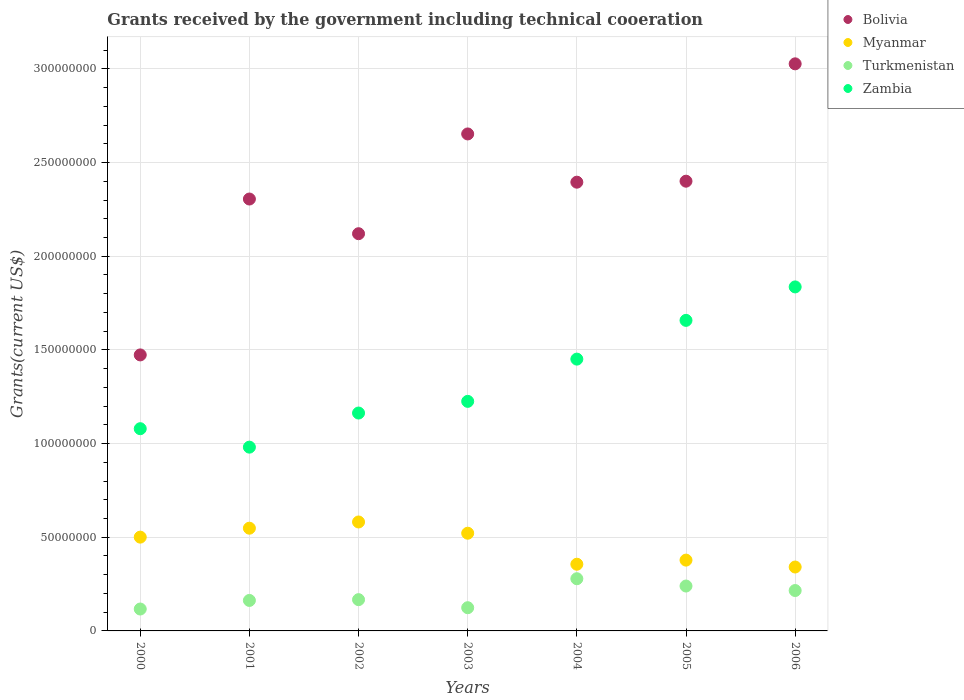How many different coloured dotlines are there?
Offer a very short reply. 4. What is the total grants received by the government in Myanmar in 2006?
Your answer should be very brief. 3.41e+07. Across all years, what is the maximum total grants received by the government in Bolivia?
Your answer should be compact. 3.03e+08. Across all years, what is the minimum total grants received by the government in Myanmar?
Keep it short and to the point. 3.41e+07. In which year was the total grants received by the government in Turkmenistan minimum?
Your answer should be very brief. 2000. What is the total total grants received by the government in Zambia in the graph?
Give a very brief answer. 9.39e+08. What is the difference between the total grants received by the government in Myanmar in 2001 and that in 2005?
Provide a succinct answer. 1.70e+07. What is the difference between the total grants received by the government in Zambia in 2004 and the total grants received by the government in Bolivia in 2002?
Your response must be concise. -6.69e+07. What is the average total grants received by the government in Myanmar per year?
Provide a succinct answer. 4.61e+07. In the year 2000, what is the difference between the total grants received by the government in Zambia and total grants received by the government in Myanmar?
Keep it short and to the point. 5.79e+07. What is the ratio of the total grants received by the government in Myanmar in 2001 to that in 2006?
Offer a very short reply. 1.61. Is the total grants received by the government in Bolivia in 2003 less than that in 2004?
Give a very brief answer. No. What is the difference between the highest and the second highest total grants received by the government in Zambia?
Offer a terse response. 1.79e+07. What is the difference between the highest and the lowest total grants received by the government in Bolivia?
Offer a very short reply. 1.55e+08. Is it the case that in every year, the sum of the total grants received by the government in Turkmenistan and total grants received by the government in Bolivia  is greater than the total grants received by the government in Zambia?
Keep it short and to the point. Yes. Does the total grants received by the government in Myanmar monotonically increase over the years?
Keep it short and to the point. No. Is the total grants received by the government in Zambia strictly greater than the total grants received by the government in Bolivia over the years?
Make the answer very short. No. Is the total grants received by the government in Zambia strictly less than the total grants received by the government in Bolivia over the years?
Your answer should be very brief. Yes. Are the values on the major ticks of Y-axis written in scientific E-notation?
Offer a terse response. No. Does the graph contain any zero values?
Provide a succinct answer. No. Where does the legend appear in the graph?
Make the answer very short. Top right. How many legend labels are there?
Give a very brief answer. 4. What is the title of the graph?
Provide a short and direct response. Grants received by the government including technical cooeration. Does "St. Martin (French part)" appear as one of the legend labels in the graph?
Ensure brevity in your answer.  No. What is the label or title of the Y-axis?
Give a very brief answer. Grants(current US$). What is the Grants(current US$) of Bolivia in 2000?
Your answer should be compact. 1.47e+08. What is the Grants(current US$) of Myanmar in 2000?
Provide a short and direct response. 5.01e+07. What is the Grants(current US$) in Turkmenistan in 2000?
Offer a very short reply. 1.17e+07. What is the Grants(current US$) in Zambia in 2000?
Your response must be concise. 1.08e+08. What is the Grants(current US$) in Bolivia in 2001?
Keep it short and to the point. 2.31e+08. What is the Grants(current US$) of Myanmar in 2001?
Offer a very short reply. 5.48e+07. What is the Grants(current US$) of Turkmenistan in 2001?
Your answer should be very brief. 1.63e+07. What is the Grants(current US$) of Zambia in 2001?
Your response must be concise. 9.81e+07. What is the Grants(current US$) of Bolivia in 2002?
Your response must be concise. 2.12e+08. What is the Grants(current US$) in Myanmar in 2002?
Your answer should be very brief. 5.82e+07. What is the Grants(current US$) of Turkmenistan in 2002?
Provide a succinct answer. 1.67e+07. What is the Grants(current US$) of Zambia in 2002?
Give a very brief answer. 1.16e+08. What is the Grants(current US$) of Bolivia in 2003?
Provide a short and direct response. 2.65e+08. What is the Grants(current US$) of Myanmar in 2003?
Give a very brief answer. 5.22e+07. What is the Grants(current US$) of Turkmenistan in 2003?
Your answer should be compact. 1.24e+07. What is the Grants(current US$) in Zambia in 2003?
Make the answer very short. 1.23e+08. What is the Grants(current US$) in Bolivia in 2004?
Give a very brief answer. 2.40e+08. What is the Grants(current US$) in Myanmar in 2004?
Your answer should be compact. 3.56e+07. What is the Grants(current US$) of Turkmenistan in 2004?
Make the answer very short. 2.79e+07. What is the Grants(current US$) of Zambia in 2004?
Keep it short and to the point. 1.45e+08. What is the Grants(current US$) in Bolivia in 2005?
Your answer should be very brief. 2.40e+08. What is the Grants(current US$) in Myanmar in 2005?
Offer a terse response. 3.78e+07. What is the Grants(current US$) of Turkmenistan in 2005?
Your answer should be compact. 2.40e+07. What is the Grants(current US$) of Zambia in 2005?
Offer a very short reply. 1.66e+08. What is the Grants(current US$) of Bolivia in 2006?
Ensure brevity in your answer.  3.03e+08. What is the Grants(current US$) of Myanmar in 2006?
Offer a terse response. 3.41e+07. What is the Grants(current US$) of Turkmenistan in 2006?
Provide a succinct answer. 2.16e+07. What is the Grants(current US$) of Zambia in 2006?
Make the answer very short. 1.84e+08. Across all years, what is the maximum Grants(current US$) in Bolivia?
Offer a very short reply. 3.03e+08. Across all years, what is the maximum Grants(current US$) in Myanmar?
Your response must be concise. 5.82e+07. Across all years, what is the maximum Grants(current US$) in Turkmenistan?
Your answer should be compact. 2.79e+07. Across all years, what is the maximum Grants(current US$) in Zambia?
Make the answer very short. 1.84e+08. Across all years, what is the minimum Grants(current US$) of Bolivia?
Your response must be concise. 1.47e+08. Across all years, what is the minimum Grants(current US$) in Myanmar?
Your response must be concise. 3.41e+07. Across all years, what is the minimum Grants(current US$) in Turkmenistan?
Keep it short and to the point. 1.17e+07. Across all years, what is the minimum Grants(current US$) of Zambia?
Offer a very short reply. 9.81e+07. What is the total Grants(current US$) in Bolivia in the graph?
Give a very brief answer. 1.64e+09. What is the total Grants(current US$) in Myanmar in the graph?
Make the answer very short. 3.23e+08. What is the total Grants(current US$) of Turkmenistan in the graph?
Provide a short and direct response. 1.30e+08. What is the total Grants(current US$) of Zambia in the graph?
Offer a very short reply. 9.39e+08. What is the difference between the Grants(current US$) in Bolivia in 2000 and that in 2001?
Offer a terse response. -8.32e+07. What is the difference between the Grants(current US$) of Myanmar in 2000 and that in 2001?
Provide a succinct answer. -4.77e+06. What is the difference between the Grants(current US$) in Turkmenistan in 2000 and that in 2001?
Keep it short and to the point. -4.58e+06. What is the difference between the Grants(current US$) of Zambia in 2000 and that in 2001?
Offer a very short reply. 9.85e+06. What is the difference between the Grants(current US$) of Bolivia in 2000 and that in 2002?
Make the answer very short. -6.47e+07. What is the difference between the Grants(current US$) of Myanmar in 2000 and that in 2002?
Your response must be concise. -8.09e+06. What is the difference between the Grants(current US$) of Turkmenistan in 2000 and that in 2002?
Your answer should be compact. -5.00e+06. What is the difference between the Grants(current US$) in Zambia in 2000 and that in 2002?
Your answer should be very brief. -8.36e+06. What is the difference between the Grants(current US$) of Bolivia in 2000 and that in 2003?
Provide a succinct answer. -1.18e+08. What is the difference between the Grants(current US$) of Myanmar in 2000 and that in 2003?
Make the answer very short. -2.09e+06. What is the difference between the Grants(current US$) in Turkmenistan in 2000 and that in 2003?
Keep it short and to the point. -7.00e+05. What is the difference between the Grants(current US$) of Zambia in 2000 and that in 2003?
Give a very brief answer. -1.46e+07. What is the difference between the Grants(current US$) in Bolivia in 2000 and that in 2004?
Give a very brief answer. -9.22e+07. What is the difference between the Grants(current US$) of Myanmar in 2000 and that in 2004?
Your answer should be very brief. 1.45e+07. What is the difference between the Grants(current US$) of Turkmenistan in 2000 and that in 2004?
Keep it short and to the point. -1.62e+07. What is the difference between the Grants(current US$) of Zambia in 2000 and that in 2004?
Your response must be concise. -3.71e+07. What is the difference between the Grants(current US$) in Bolivia in 2000 and that in 2005?
Your response must be concise. -9.27e+07. What is the difference between the Grants(current US$) in Myanmar in 2000 and that in 2005?
Ensure brevity in your answer.  1.23e+07. What is the difference between the Grants(current US$) in Turkmenistan in 2000 and that in 2005?
Offer a very short reply. -1.23e+07. What is the difference between the Grants(current US$) of Zambia in 2000 and that in 2005?
Offer a terse response. -5.78e+07. What is the difference between the Grants(current US$) in Bolivia in 2000 and that in 2006?
Keep it short and to the point. -1.55e+08. What is the difference between the Grants(current US$) in Myanmar in 2000 and that in 2006?
Keep it short and to the point. 1.60e+07. What is the difference between the Grants(current US$) of Turkmenistan in 2000 and that in 2006?
Ensure brevity in your answer.  -9.87e+06. What is the difference between the Grants(current US$) in Zambia in 2000 and that in 2006?
Provide a short and direct response. -7.57e+07. What is the difference between the Grants(current US$) in Bolivia in 2001 and that in 2002?
Ensure brevity in your answer.  1.85e+07. What is the difference between the Grants(current US$) in Myanmar in 2001 and that in 2002?
Offer a very short reply. -3.32e+06. What is the difference between the Grants(current US$) of Turkmenistan in 2001 and that in 2002?
Make the answer very short. -4.20e+05. What is the difference between the Grants(current US$) of Zambia in 2001 and that in 2002?
Provide a short and direct response. -1.82e+07. What is the difference between the Grants(current US$) in Bolivia in 2001 and that in 2003?
Give a very brief answer. -3.47e+07. What is the difference between the Grants(current US$) of Myanmar in 2001 and that in 2003?
Ensure brevity in your answer.  2.68e+06. What is the difference between the Grants(current US$) of Turkmenistan in 2001 and that in 2003?
Your answer should be very brief. 3.88e+06. What is the difference between the Grants(current US$) of Zambia in 2001 and that in 2003?
Give a very brief answer. -2.44e+07. What is the difference between the Grants(current US$) of Bolivia in 2001 and that in 2004?
Your answer should be very brief. -8.99e+06. What is the difference between the Grants(current US$) in Myanmar in 2001 and that in 2004?
Offer a terse response. 1.92e+07. What is the difference between the Grants(current US$) of Turkmenistan in 2001 and that in 2004?
Keep it short and to the point. -1.16e+07. What is the difference between the Grants(current US$) in Zambia in 2001 and that in 2004?
Give a very brief answer. -4.70e+07. What is the difference between the Grants(current US$) of Bolivia in 2001 and that in 2005?
Keep it short and to the point. -9.52e+06. What is the difference between the Grants(current US$) of Myanmar in 2001 and that in 2005?
Provide a short and direct response. 1.70e+07. What is the difference between the Grants(current US$) in Turkmenistan in 2001 and that in 2005?
Offer a very short reply. -7.69e+06. What is the difference between the Grants(current US$) in Zambia in 2001 and that in 2005?
Provide a short and direct response. -6.77e+07. What is the difference between the Grants(current US$) in Bolivia in 2001 and that in 2006?
Your response must be concise. -7.22e+07. What is the difference between the Grants(current US$) of Myanmar in 2001 and that in 2006?
Offer a terse response. 2.07e+07. What is the difference between the Grants(current US$) of Turkmenistan in 2001 and that in 2006?
Give a very brief answer. -5.29e+06. What is the difference between the Grants(current US$) in Zambia in 2001 and that in 2006?
Your response must be concise. -8.55e+07. What is the difference between the Grants(current US$) in Bolivia in 2002 and that in 2003?
Offer a very short reply. -5.32e+07. What is the difference between the Grants(current US$) in Turkmenistan in 2002 and that in 2003?
Offer a terse response. 4.30e+06. What is the difference between the Grants(current US$) of Zambia in 2002 and that in 2003?
Your response must be concise. -6.23e+06. What is the difference between the Grants(current US$) of Bolivia in 2002 and that in 2004?
Give a very brief answer. -2.75e+07. What is the difference between the Grants(current US$) of Myanmar in 2002 and that in 2004?
Provide a short and direct response. 2.26e+07. What is the difference between the Grants(current US$) of Turkmenistan in 2002 and that in 2004?
Provide a short and direct response. -1.12e+07. What is the difference between the Grants(current US$) in Zambia in 2002 and that in 2004?
Make the answer very short. -2.88e+07. What is the difference between the Grants(current US$) in Bolivia in 2002 and that in 2005?
Make the answer very short. -2.80e+07. What is the difference between the Grants(current US$) of Myanmar in 2002 and that in 2005?
Your answer should be very brief. 2.04e+07. What is the difference between the Grants(current US$) of Turkmenistan in 2002 and that in 2005?
Keep it short and to the point. -7.27e+06. What is the difference between the Grants(current US$) in Zambia in 2002 and that in 2005?
Ensure brevity in your answer.  -4.95e+07. What is the difference between the Grants(current US$) in Bolivia in 2002 and that in 2006?
Give a very brief answer. -9.07e+07. What is the difference between the Grants(current US$) in Myanmar in 2002 and that in 2006?
Offer a very short reply. 2.40e+07. What is the difference between the Grants(current US$) of Turkmenistan in 2002 and that in 2006?
Keep it short and to the point. -4.87e+06. What is the difference between the Grants(current US$) of Zambia in 2002 and that in 2006?
Give a very brief answer. -6.73e+07. What is the difference between the Grants(current US$) in Bolivia in 2003 and that in 2004?
Your answer should be very brief. 2.58e+07. What is the difference between the Grants(current US$) of Myanmar in 2003 and that in 2004?
Provide a succinct answer. 1.66e+07. What is the difference between the Grants(current US$) of Turkmenistan in 2003 and that in 2004?
Your response must be concise. -1.55e+07. What is the difference between the Grants(current US$) in Zambia in 2003 and that in 2004?
Make the answer very short. -2.26e+07. What is the difference between the Grants(current US$) of Bolivia in 2003 and that in 2005?
Offer a very short reply. 2.52e+07. What is the difference between the Grants(current US$) of Myanmar in 2003 and that in 2005?
Give a very brief answer. 1.44e+07. What is the difference between the Grants(current US$) in Turkmenistan in 2003 and that in 2005?
Keep it short and to the point. -1.16e+07. What is the difference between the Grants(current US$) in Zambia in 2003 and that in 2005?
Make the answer very short. -4.32e+07. What is the difference between the Grants(current US$) in Bolivia in 2003 and that in 2006?
Offer a terse response. -3.74e+07. What is the difference between the Grants(current US$) of Myanmar in 2003 and that in 2006?
Your answer should be compact. 1.80e+07. What is the difference between the Grants(current US$) of Turkmenistan in 2003 and that in 2006?
Give a very brief answer. -9.17e+06. What is the difference between the Grants(current US$) of Zambia in 2003 and that in 2006?
Your response must be concise. -6.11e+07. What is the difference between the Grants(current US$) of Bolivia in 2004 and that in 2005?
Provide a succinct answer. -5.30e+05. What is the difference between the Grants(current US$) of Myanmar in 2004 and that in 2005?
Your answer should be very brief. -2.19e+06. What is the difference between the Grants(current US$) in Turkmenistan in 2004 and that in 2005?
Provide a succinct answer. 3.90e+06. What is the difference between the Grants(current US$) in Zambia in 2004 and that in 2005?
Offer a very short reply. -2.07e+07. What is the difference between the Grants(current US$) of Bolivia in 2004 and that in 2006?
Ensure brevity in your answer.  -6.32e+07. What is the difference between the Grants(current US$) of Myanmar in 2004 and that in 2006?
Keep it short and to the point. 1.49e+06. What is the difference between the Grants(current US$) in Turkmenistan in 2004 and that in 2006?
Make the answer very short. 6.30e+06. What is the difference between the Grants(current US$) in Zambia in 2004 and that in 2006?
Your answer should be compact. -3.85e+07. What is the difference between the Grants(current US$) of Bolivia in 2005 and that in 2006?
Provide a short and direct response. -6.26e+07. What is the difference between the Grants(current US$) in Myanmar in 2005 and that in 2006?
Keep it short and to the point. 3.68e+06. What is the difference between the Grants(current US$) of Turkmenistan in 2005 and that in 2006?
Offer a terse response. 2.40e+06. What is the difference between the Grants(current US$) in Zambia in 2005 and that in 2006?
Ensure brevity in your answer.  -1.79e+07. What is the difference between the Grants(current US$) of Bolivia in 2000 and the Grants(current US$) of Myanmar in 2001?
Your answer should be very brief. 9.25e+07. What is the difference between the Grants(current US$) of Bolivia in 2000 and the Grants(current US$) of Turkmenistan in 2001?
Offer a very short reply. 1.31e+08. What is the difference between the Grants(current US$) in Bolivia in 2000 and the Grants(current US$) in Zambia in 2001?
Make the answer very short. 4.92e+07. What is the difference between the Grants(current US$) in Myanmar in 2000 and the Grants(current US$) in Turkmenistan in 2001?
Provide a succinct answer. 3.38e+07. What is the difference between the Grants(current US$) of Myanmar in 2000 and the Grants(current US$) of Zambia in 2001?
Offer a very short reply. -4.80e+07. What is the difference between the Grants(current US$) of Turkmenistan in 2000 and the Grants(current US$) of Zambia in 2001?
Your answer should be compact. -8.64e+07. What is the difference between the Grants(current US$) of Bolivia in 2000 and the Grants(current US$) of Myanmar in 2002?
Make the answer very short. 8.92e+07. What is the difference between the Grants(current US$) in Bolivia in 2000 and the Grants(current US$) in Turkmenistan in 2002?
Give a very brief answer. 1.31e+08. What is the difference between the Grants(current US$) of Bolivia in 2000 and the Grants(current US$) of Zambia in 2002?
Provide a short and direct response. 3.10e+07. What is the difference between the Grants(current US$) in Myanmar in 2000 and the Grants(current US$) in Turkmenistan in 2002?
Your response must be concise. 3.34e+07. What is the difference between the Grants(current US$) in Myanmar in 2000 and the Grants(current US$) in Zambia in 2002?
Offer a terse response. -6.62e+07. What is the difference between the Grants(current US$) of Turkmenistan in 2000 and the Grants(current US$) of Zambia in 2002?
Offer a very short reply. -1.05e+08. What is the difference between the Grants(current US$) in Bolivia in 2000 and the Grants(current US$) in Myanmar in 2003?
Provide a succinct answer. 9.52e+07. What is the difference between the Grants(current US$) of Bolivia in 2000 and the Grants(current US$) of Turkmenistan in 2003?
Offer a terse response. 1.35e+08. What is the difference between the Grants(current US$) of Bolivia in 2000 and the Grants(current US$) of Zambia in 2003?
Make the answer very short. 2.48e+07. What is the difference between the Grants(current US$) in Myanmar in 2000 and the Grants(current US$) in Turkmenistan in 2003?
Offer a terse response. 3.77e+07. What is the difference between the Grants(current US$) of Myanmar in 2000 and the Grants(current US$) of Zambia in 2003?
Offer a very short reply. -7.25e+07. What is the difference between the Grants(current US$) of Turkmenistan in 2000 and the Grants(current US$) of Zambia in 2003?
Ensure brevity in your answer.  -1.11e+08. What is the difference between the Grants(current US$) of Bolivia in 2000 and the Grants(current US$) of Myanmar in 2004?
Offer a very short reply. 1.12e+08. What is the difference between the Grants(current US$) of Bolivia in 2000 and the Grants(current US$) of Turkmenistan in 2004?
Provide a short and direct response. 1.19e+08. What is the difference between the Grants(current US$) in Bolivia in 2000 and the Grants(current US$) in Zambia in 2004?
Your response must be concise. 2.24e+06. What is the difference between the Grants(current US$) in Myanmar in 2000 and the Grants(current US$) in Turkmenistan in 2004?
Offer a very short reply. 2.22e+07. What is the difference between the Grants(current US$) in Myanmar in 2000 and the Grants(current US$) in Zambia in 2004?
Ensure brevity in your answer.  -9.50e+07. What is the difference between the Grants(current US$) of Turkmenistan in 2000 and the Grants(current US$) of Zambia in 2004?
Your answer should be very brief. -1.33e+08. What is the difference between the Grants(current US$) of Bolivia in 2000 and the Grants(current US$) of Myanmar in 2005?
Give a very brief answer. 1.10e+08. What is the difference between the Grants(current US$) in Bolivia in 2000 and the Grants(current US$) in Turkmenistan in 2005?
Keep it short and to the point. 1.23e+08. What is the difference between the Grants(current US$) in Bolivia in 2000 and the Grants(current US$) in Zambia in 2005?
Provide a succinct answer. -1.84e+07. What is the difference between the Grants(current US$) of Myanmar in 2000 and the Grants(current US$) of Turkmenistan in 2005?
Your answer should be very brief. 2.61e+07. What is the difference between the Grants(current US$) of Myanmar in 2000 and the Grants(current US$) of Zambia in 2005?
Provide a short and direct response. -1.16e+08. What is the difference between the Grants(current US$) in Turkmenistan in 2000 and the Grants(current US$) in Zambia in 2005?
Offer a terse response. -1.54e+08. What is the difference between the Grants(current US$) in Bolivia in 2000 and the Grants(current US$) in Myanmar in 2006?
Your response must be concise. 1.13e+08. What is the difference between the Grants(current US$) of Bolivia in 2000 and the Grants(current US$) of Turkmenistan in 2006?
Offer a very short reply. 1.26e+08. What is the difference between the Grants(current US$) of Bolivia in 2000 and the Grants(current US$) of Zambia in 2006?
Provide a short and direct response. -3.63e+07. What is the difference between the Grants(current US$) in Myanmar in 2000 and the Grants(current US$) in Turkmenistan in 2006?
Your response must be concise. 2.85e+07. What is the difference between the Grants(current US$) of Myanmar in 2000 and the Grants(current US$) of Zambia in 2006?
Offer a very short reply. -1.34e+08. What is the difference between the Grants(current US$) in Turkmenistan in 2000 and the Grants(current US$) in Zambia in 2006?
Your response must be concise. -1.72e+08. What is the difference between the Grants(current US$) of Bolivia in 2001 and the Grants(current US$) of Myanmar in 2002?
Offer a very short reply. 1.72e+08. What is the difference between the Grants(current US$) in Bolivia in 2001 and the Grants(current US$) in Turkmenistan in 2002?
Offer a very short reply. 2.14e+08. What is the difference between the Grants(current US$) in Bolivia in 2001 and the Grants(current US$) in Zambia in 2002?
Give a very brief answer. 1.14e+08. What is the difference between the Grants(current US$) in Myanmar in 2001 and the Grants(current US$) in Turkmenistan in 2002?
Make the answer very short. 3.81e+07. What is the difference between the Grants(current US$) of Myanmar in 2001 and the Grants(current US$) of Zambia in 2002?
Provide a succinct answer. -6.15e+07. What is the difference between the Grants(current US$) in Turkmenistan in 2001 and the Grants(current US$) in Zambia in 2002?
Your answer should be very brief. -1.00e+08. What is the difference between the Grants(current US$) of Bolivia in 2001 and the Grants(current US$) of Myanmar in 2003?
Offer a very short reply. 1.78e+08. What is the difference between the Grants(current US$) of Bolivia in 2001 and the Grants(current US$) of Turkmenistan in 2003?
Offer a very short reply. 2.18e+08. What is the difference between the Grants(current US$) in Bolivia in 2001 and the Grants(current US$) in Zambia in 2003?
Keep it short and to the point. 1.08e+08. What is the difference between the Grants(current US$) of Myanmar in 2001 and the Grants(current US$) of Turkmenistan in 2003?
Offer a terse response. 4.24e+07. What is the difference between the Grants(current US$) in Myanmar in 2001 and the Grants(current US$) in Zambia in 2003?
Offer a very short reply. -6.77e+07. What is the difference between the Grants(current US$) of Turkmenistan in 2001 and the Grants(current US$) of Zambia in 2003?
Your answer should be compact. -1.06e+08. What is the difference between the Grants(current US$) of Bolivia in 2001 and the Grants(current US$) of Myanmar in 2004?
Offer a very short reply. 1.95e+08. What is the difference between the Grants(current US$) of Bolivia in 2001 and the Grants(current US$) of Turkmenistan in 2004?
Your response must be concise. 2.03e+08. What is the difference between the Grants(current US$) in Bolivia in 2001 and the Grants(current US$) in Zambia in 2004?
Give a very brief answer. 8.54e+07. What is the difference between the Grants(current US$) of Myanmar in 2001 and the Grants(current US$) of Turkmenistan in 2004?
Keep it short and to the point. 2.70e+07. What is the difference between the Grants(current US$) in Myanmar in 2001 and the Grants(current US$) in Zambia in 2004?
Your response must be concise. -9.02e+07. What is the difference between the Grants(current US$) in Turkmenistan in 2001 and the Grants(current US$) in Zambia in 2004?
Make the answer very short. -1.29e+08. What is the difference between the Grants(current US$) in Bolivia in 2001 and the Grants(current US$) in Myanmar in 2005?
Ensure brevity in your answer.  1.93e+08. What is the difference between the Grants(current US$) in Bolivia in 2001 and the Grants(current US$) in Turkmenistan in 2005?
Your response must be concise. 2.07e+08. What is the difference between the Grants(current US$) in Bolivia in 2001 and the Grants(current US$) in Zambia in 2005?
Offer a terse response. 6.48e+07. What is the difference between the Grants(current US$) in Myanmar in 2001 and the Grants(current US$) in Turkmenistan in 2005?
Keep it short and to the point. 3.09e+07. What is the difference between the Grants(current US$) in Myanmar in 2001 and the Grants(current US$) in Zambia in 2005?
Offer a terse response. -1.11e+08. What is the difference between the Grants(current US$) in Turkmenistan in 2001 and the Grants(current US$) in Zambia in 2005?
Ensure brevity in your answer.  -1.49e+08. What is the difference between the Grants(current US$) in Bolivia in 2001 and the Grants(current US$) in Myanmar in 2006?
Provide a short and direct response. 1.96e+08. What is the difference between the Grants(current US$) of Bolivia in 2001 and the Grants(current US$) of Turkmenistan in 2006?
Your answer should be very brief. 2.09e+08. What is the difference between the Grants(current US$) of Bolivia in 2001 and the Grants(current US$) of Zambia in 2006?
Provide a short and direct response. 4.69e+07. What is the difference between the Grants(current US$) of Myanmar in 2001 and the Grants(current US$) of Turkmenistan in 2006?
Your answer should be very brief. 3.33e+07. What is the difference between the Grants(current US$) of Myanmar in 2001 and the Grants(current US$) of Zambia in 2006?
Keep it short and to the point. -1.29e+08. What is the difference between the Grants(current US$) in Turkmenistan in 2001 and the Grants(current US$) in Zambia in 2006?
Give a very brief answer. -1.67e+08. What is the difference between the Grants(current US$) of Bolivia in 2002 and the Grants(current US$) of Myanmar in 2003?
Your answer should be compact. 1.60e+08. What is the difference between the Grants(current US$) in Bolivia in 2002 and the Grants(current US$) in Turkmenistan in 2003?
Your answer should be compact. 2.00e+08. What is the difference between the Grants(current US$) of Bolivia in 2002 and the Grants(current US$) of Zambia in 2003?
Ensure brevity in your answer.  8.95e+07. What is the difference between the Grants(current US$) in Myanmar in 2002 and the Grants(current US$) in Turkmenistan in 2003?
Offer a very short reply. 4.58e+07. What is the difference between the Grants(current US$) of Myanmar in 2002 and the Grants(current US$) of Zambia in 2003?
Ensure brevity in your answer.  -6.44e+07. What is the difference between the Grants(current US$) of Turkmenistan in 2002 and the Grants(current US$) of Zambia in 2003?
Offer a terse response. -1.06e+08. What is the difference between the Grants(current US$) in Bolivia in 2002 and the Grants(current US$) in Myanmar in 2004?
Give a very brief answer. 1.76e+08. What is the difference between the Grants(current US$) of Bolivia in 2002 and the Grants(current US$) of Turkmenistan in 2004?
Ensure brevity in your answer.  1.84e+08. What is the difference between the Grants(current US$) in Bolivia in 2002 and the Grants(current US$) in Zambia in 2004?
Make the answer very short. 6.69e+07. What is the difference between the Grants(current US$) in Myanmar in 2002 and the Grants(current US$) in Turkmenistan in 2004?
Offer a terse response. 3.03e+07. What is the difference between the Grants(current US$) of Myanmar in 2002 and the Grants(current US$) of Zambia in 2004?
Offer a terse response. -8.69e+07. What is the difference between the Grants(current US$) in Turkmenistan in 2002 and the Grants(current US$) in Zambia in 2004?
Make the answer very short. -1.28e+08. What is the difference between the Grants(current US$) in Bolivia in 2002 and the Grants(current US$) in Myanmar in 2005?
Make the answer very short. 1.74e+08. What is the difference between the Grants(current US$) in Bolivia in 2002 and the Grants(current US$) in Turkmenistan in 2005?
Your answer should be compact. 1.88e+08. What is the difference between the Grants(current US$) of Bolivia in 2002 and the Grants(current US$) of Zambia in 2005?
Keep it short and to the point. 4.63e+07. What is the difference between the Grants(current US$) of Myanmar in 2002 and the Grants(current US$) of Turkmenistan in 2005?
Offer a terse response. 3.42e+07. What is the difference between the Grants(current US$) of Myanmar in 2002 and the Grants(current US$) of Zambia in 2005?
Make the answer very short. -1.08e+08. What is the difference between the Grants(current US$) in Turkmenistan in 2002 and the Grants(current US$) in Zambia in 2005?
Your response must be concise. -1.49e+08. What is the difference between the Grants(current US$) in Bolivia in 2002 and the Grants(current US$) in Myanmar in 2006?
Keep it short and to the point. 1.78e+08. What is the difference between the Grants(current US$) in Bolivia in 2002 and the Grants(current US$) in Turkmenistan in 2006?
Offer a very short reply. 1.90e+08. What is the difference between the Grants(current US$) of Bolivia in 2002 and the Grants(current US$) of Zambia in 2006?
Give a very brief answer. 2.84e+07. What is the difference between the Grants(current US$) in Myanmar in 2002 and the Grants(current US$) in Turkmenistan in 2006?
Provide a short and direct response. 3.66e+07. What is the difference between the Grants(current US$) in Myanmar in 2002 and the Grants(current US$) in Zambia in 2006?
Keep it short and to the point. -1.25e+08. What is the difference between the Grants(current US$) of Turkmenistan in 2002 and the Grants(current US$) of Zambia in 2006?
Your response must be concise. -1.67e+08. What is the difference between the Grants(current US$) of Bolivia in 2003 and the Grants(current US$) of Myanmar in 2004?
Make the answer very short. 2.30e+08. What is the difference between the Grants(current US$) of Bolivia in 2003 and the Grants(current US$) of Turkmenistan in 2004?
Your answer should be compact. 2.37e+08. What is the difference between the Grants(current US$) in Bolivia in 2003 and the Grants(current US$) in Zambia in 2004?
Make the answer very short. 1.20e+08. What is the difference between the Grants(current US$) of Myanmar in 2003 and the Grants(current US$) of Turkmenistan in 2004?
Provide a short and direct response. 2.43e+07. What is the difference between the Grants(current US$) in Myanmar in 2003 and the Grants(current US$) in Zambia in 2004?
Keep it short and to the point. -9.29e+07. What is the difference between the Grants(current US$) of Turkmenistan in 2003 and the Grants(current US$) of Zambia in 2004?
Keep it short and to the point. -1.33e+08. What is the difference between the Grants(current US$) of Bolivia in 2003 and the Grants(current US$) of Myanmar in 2005?
Your answer should be compact. 2.27e+08. What is the difference between the Grants(current US$) of Bolivia in 2003 and the Grants(current US$) of Turkmenistan in 2005?
Provide a succinct answer. 2.41e+08. What is the difference between the Grants(current US$) in Bolivia in 2003 and the Grants(current US$) in Zambia in 2005?
Your answer should be very brief. 9.95e+07. What is the difference between the Grants(current US$) of Myanmar in 2003 and the Grants(current US$) of Turkmenistan in 2005?
Your answer should be very brief. 2.82e+07. What is the difference between the Grants(current US$) of Myanmar in 2003 and the Grants(current US$) of Zambia in 2005?
Provide a short and direct response. -1.14e+08. What is the difference between the Grants(current US$) of Turkmenistan in 2003 and the Grants(current US$) of Zambia in 2005?
Ensure brevity in your answer.  -1.53e+08. What is the difference between the Grants(current US$) in Bolivia in 2003 and the Grants(current US$) in Myanmar in 2006?
Ensure brevity in your answer.  2.31e+08. What is the difference between the Grants(current US$) in Bolivia in 2003 and the Grants(current US$) in Turkmenistan in 2006?
Your response must be concise. 2.44e+08. What is the difference between the Grants(current US$) of Bolivia in 2003 and the Grants(current US$) of Zambia in 2006?
Offer a very short reply. 8.16e+07. What is the difference between the Grants(current US$) of Myanmar in 2003 and the Grants(current US$) of Turkmenistan in 2006?
Keep it short and to the point. 3.06e+07. What is the difference between the Grants(current US$) of Myanmar in 2003 and the Grants(current US$) of Zambia in 2006?
Offer a terse response. -1.31e+08. What is the difference between the Grants(current US$) of Turkmenistan in 2003 and the Grants(current US$) of Zambia in 2006?
Keep it short and to the point. -1.71e+08. What is the difference between the Grants(current US$) of Bolivia in 2004 and the Grants(current US$) of Myanmar in 2005?
Offer a terse response. 2.02e+08. What is the difference between the Grants(current US$) in Bolivia in 2004 and the Grants(current US$) in Turkmenistan in 2005?
Your answer should be very brief. 2.16e+08. What is the difference between the Grants(current US$) in Bolivia in 2004 and the Grants(current US$) in Zambia in 2005?
Your answer should be compact. 7.38e+07. What is the difference between the Grants(current US$) in Myanmar in 2004 and the Grants(current US$) in Turkmenistan in 2005?
Give a very brief answer. 1.16e+07. What is the difference between the Grants(current US$) in Myanmar in 2004 and the Grants(current US$) in Zambia in 2005?
Provide a short and direct response. -1.30e+08. What is the difference between the Grants(current US$) of Turkmenistan in 2004 and the Grants(current US$) of Zambia in 2005?
Ensure brevity in your answer.  -1.38e+08. What is the difference between the Grants(current US$) in Bolivia in 2004 and the Grants(current US$) in Myanmar in 2006?
Keep it short and to the point. 2.05e+08. What is the difference between the Grants(current US$) in Bolivia in 2004 and the Grants(current US$) in Turkmenistan in 2006?
Your answer should be compact. 2.18e+08. What is the difference between the Grants(current US$) in Bolivia in 2004 and the Grants(current US$) in Zambia in 2006?
Provide a short and direct response. 5.59e+07. What is the difference between the Grants(current US$) in Myanmar in 2004 and the Grants(current US$) in Turkmenistan in 2006?
Your answer should be compact. 1.40e+07. What is the difference between the Grants(current US$) in Myanmar in 2004 and the Grants(current US$) in Zambia in 2006?
Provide a succinct answer. -1.48e+08. What is the difference between the Grants(current US$) of Turkmenistan in 2004 and the Grants(current US$) of Zambia in 2006?
Your answer should be very brief. -1.56e+08. What is the difference between the Grants(current US$) of Bolivia in 2005 and the Grants(current US$) of Myanmar in 2006?
Give a very brief answer. 2.06e+08. What is the difference between the Grants(current US$) in Bolivia in 2005 and the Grants(current US$) in Turkmenistan in 2006?
Offer a terse response. 2.18e+08. What is the difference between the Grants(current US$) in Bolivia in 2005 and the Grants(current US$) in Zambia in 2006?
Provide a short and direct response. 5.64e+07. What is the difference between the Grants(current US$) of Myanmar in 2005 and the Grants(current US$) of Turkmenistan in 2006?
Offer a very short reply. 1.62e+07. What is the difference between the Grants(current US$) of Myanmar in 2005 and the Grants(current US$) of Zambia in 2006?
Your answer should be very brief. -1.46e+08. What is the difference between the Grants(current US$) in Turkmenistan in 2005 and the Grants(current US$) in Zambia in 2006?
Your answer should be very brief. -1.60e+08. What is the average Grants(current US$) in Bolivia per year?
Offer a terse response. 2.34e+08. What is the average Grants(current US$) in Myanmar per year?
Keep it short and to the point. 4.61e+07. What is the average Grants(current US$) in Turkmenistan per year?
Offer a very short reply. 1.86e+07. What is the average Grants(current US$) of Zambia per year?
Offer a terse response. 1.34e+08. In the year 2000, what is the difference between the Grants(current US$) of Bolivia and Grants(current US$) of Myanmar?
Your response must be concise. 9.73e+07. In the year 2000, what is the difference between the Grants(current US$) of Bolivia and Grants(current US$) of Turkmenistan?
Make the answer very short. 1.36e+08. In the year 2000, what is the difference between the Grants(current US$) of Bolivia and Grants(current US$) of Zambia?
Provide a short and direct response. 3.94e+07. In the year 2000, what is the difference between the Grants(current US$) of Myanmar and Grants(current US$) of Turkmenistan?
Your answer should be compact. 3.84e+07. In the year 2000, what is the difference between the Grants(current US$) in Myanmar and Grants(current US$) in Zambia?
Your response must be concise. -5.79e+07. In the year 2000, what is the difference between the Grants(current US$) of Turkmenistan and Grants(current US$) of Zambia?
Ensure brevity in your answer.  -9.62e+07. In the year 2001, what is the difference between the Grants(current US$) of Bolivia and Grants(current US$) of Myanmar?
Your answer should be very brief. 1.76e+08. In the year 2001, what is the difference between the Grants(current US$) of Bolivia and Grants(current US$) of Turkmenistan?
Your answer should be compact. 2.14e+08. In the year 2001, what is the difference between the Grants(current US$) of Bolivia and Grants(current US$) of Zambia?
Provide a succinct answer. 1.32e+08. In the year 2001, what is the difference between the Grants(current US$) in Myanmar and Grants(current US$) in Turkmenistan?
Offer a terse response. 3.86e+07. In the year 2001, what is the difference between the Grants(current US$) in Myanmar and Grants(current US$) in Zambia?
Offer a terse response. -4.33e+07. In the year 2001, what is the difference between the Grants(current US$) in Turkmenistan and Grants(current US$) in Zambia?
Ensure brevity in your answer.  -8.18e+07. In the year 2002, what is the difference between the Grants(current US$) of Bolivia and Grants(current US$) of Myanmar?
Provide a short and direct response. 1.54e+08. In the year 2002, what is the difference between the Grants(current US$) in Bolivia and Grants(current US$) in Turkmenistan?
Make the answer very short. 1.95e+08. In the year 2002, what is the difference between the Grants(current US$) in Bolivia and Grants(current US$) in Zambia?
Give a very brief answer. 9.57e+07. In the year 2002, what is the difference between the Grants(current US$) of Myanmar and Grants(current US$) of Turkmenistan?
Your answer should be compact. 4.15e+07. In the year 2002, what is the difference between the Grants(current US$) of Myanmar and Grants(current US$) of Zambia?
Keep it short and to the point. -5.82e+07. In the year 2002, what is the difference between the Grants(current US$) of Turkmenistan and Grants(current US$) of Zambia?
Provide a short and direct response. -9.96e+07. In the year 2003, what is the difference between the Grants(current US$) of Bolivia and Grants(current US$) of Myanmar?
Ensure brevity in your answer.  2.13e+08. In the year 2003, what is the difference between the Grants(current US$) in Bolivia and Grants(current US$) in Turkmenistan?
Keep it short and to the point. 2.53e+08. In the year 2003, what is the difference between the Grants(current US$) in Bolivia and Grants(current US$) in Zambia?
Provide a succinct answer. 1.43e+08. In the year 2003, what is the difference between the Grants(current US$) in Myanmar and Grants(current US$) in Turkmenistan?
Offer a very short reply. 3.98e+07. In the year 2003, what is the difference between the Grants(current US$) of Myanmar and Grants(current US$) of Zambia?
Offer a terse response. -7.04e+07. In the year 2003, what is the difference between the Grants(current US$) in Turkmenistan and Grants(current US$) in Zambia?
Make the answer very short. -1.10e+08. In the year 2004, what is the difference between the Grants(current US$) of Bolivia and Grants(current US$) of Myanmar?
Offer a very short reply. 2.04e+08. In the year 2004, what is the difference between the Grants(current US$) in Bolivia and Grants(current US$) in Turkmenistan?
Make the answer very short. 2.12e+08. In the year 2004, what is the difference between the Grants(current US$) of Bolivia and Grants(current US$) of Zambia?
Give a very brief answer. 9.44e+07. In the year 2004, what is the difference between the Grants(current US$) in Myanmar and Grants(current US$) in Turkmenistan?
Keep it short and to the point. 7.74e+06. In the year 2004, what is the difference between the Grants(current US$) of Myanmar and Grants(current US$) of Zambia?
Provide a succinct answer. -1.09e+08. In the year 2004, what is the difference between the Grants(current US$) of Turkmenistan and Grants(current US$) of Zambia?
Provide a short and direct response. -1.17e+08. In the year 2005, what is the difference between the Grants(current US$) in Bolivia and Grants(current US$) in Myanmar?
Provide a short and direct response. 2.02e+08. In the year 2005, what is the difference between the Grants(current US$) of Bolivia and Grants(current US$) of Turkmenistan?
Offer a very short reply. 2.16e+08. In the year 2005, what is the difference between the Grants(current US$) in Bolivia and Grants(current US$) in Zambia?
Ensure brevity in your answer.  7.43e+07. In the year 2005, what is the difference between the Grants(current US$) of Myanmar and Grants(current US$) of Turkmenistan?
Offer a terse response. 1.38e+07. In the year 2005, what is the difference between the Grants(current US$) in Myanmar and Grants(current US$) in Zambia?
Your answer should be compact. -1.28e+08. In the year 2005, what is the difference between the Grants(current US$) in Turkmenistan and Grants(current US$) in Zambia?
Keep it short and to the point. -1.42e+08. In the year 2006, what is the difference between the Grants(current US$) of Bolivia and Grants(current US$) of Myanmar?
Your answer should be compact. 2.69e+08. In the year 2006, what is the difference between the Grants(current US$) in Bolivia and Grants(current US$) in Turkmenistan?
Provide a short and direct response. 2.81e+08. In the year 2006, what is the difference between the Grants(current US$) in Bolivia and Grants(current US$) in Zambia?
Your response must be concise. 1.19e+08. In the year 2006, what is the difference between the Grants(current US$) in Myanmar and Grants(current US$) in Turkmenistan?
Your answer should be compact. 1.26e+07. In the year 2006, what is the difference between the Grants(current US$) of Myanmar and Grants(current US$) of Zambia?
Provide a succinct answer. -1.50e+08. In the year 2006, what is the difference between the Grants(current US$) of Turkmenistan and Grants(current US$) of Zambia?
Your response must be concise. -1.62e+08. What is the ratio of the Grants(current US$) of Bolivia in 2000 to that in 2001?
Keep it short and to the point. 0.64. What is the ratio of the Grants(current US$) in Myanmar in 2000 to that in 2001?
Ensure brevity in your answer.  0.91. What is the ratio of the Grants(current US$) of Turkmenistan in 2000 to that in 2001?
Give a very brief answer. 0.72. What is the ratio of the Grants(current US$) of Zambia in 2000 to that in 2001?
Your response must be concise. 1.1. What is the ratio of the Grants(current US$) of Bolivia in 2000 to that in 2002?
Provide a short and direct response. 0.69. What is the ratio of the Grants(current US$) in Myanmar in 2000 to that in 2002?
Keep it short and to the point. 0.86. What is the ratio of the Grants(current US$) in Turkmenistan in 2000 to that in 2002?
Provide a succinct answer. 0.7. What is the ratio of the Grants(current US$) of Zambia in 2000 to that in 2002?
Keep it short and to the point. 0.93. What is the ratio of the Grants(current US$) in Bolivia in 2000 to that in 2003?
Offer a terse response. 0.56. What is the ratio of the Grants(current US$) of Myanmar in 2000 to that in 2003?
Your response must be concise. 0.96. What is the ratio of the Grants(current US$) of Turkmenistan in 2000 to that in 2003?
Provide a short and direct response. 0.94. What is the ratio of the Grants(current US$) of Zambia in 2000 to that in 2003?
Ensure brevity in your answer.  0.88. What is the ratio of the Grants(current US$) in Bolivia in 2000 to that in 2004?
Ensure brevity in your answer.  0.62. What is the ratio of the Grants(current US$) of Myanmar in 2000 to that in 2004?
Your answer should be compact. 1.41. What is the ratio of the Grants(current US$) of Turkmenistan in 2000 to that in 2004?
Provide a short and direct response. 0.42. What is the ratio of the Grants(current US$) of Zambia in 2000 to that in 2004?
Ensure brevity in your answer.  0.74. What is the ratio of the Grants(current US$) in Bolivia in 2000 to that in 2005?
Your answer should be compact. 0.61. What is the ratio of the Grants(current US$) of Myanmar in 2000 to that in 2005?
Keep it short and to the point. 1.32. What is the ratio of the Grants(current US$) of Turkmenistan in 2000 to that in 2005?
Keep it short and to the point. 0.49. What is the ratio of the Grants(current US$) of Zambia in 2000 to that in 2005?
Give a very brief answer. 0.65. What is the ratio of the Grants(current US$) in Bolivia in 2000 to that in 2006?
Ensure brevity in your answer.  0.49. What is the ratio of the Grants(current US$) in Myanmar in 2000 to that in 2006?
Provide a short and direct response. 1.47. What is the ratio of the Grants(current US$) of Turkmenistan in 2000 to that in 2006?
Provide a succinct answer. 0.54. What is the ratio of the Grants(current US$) in Zambia in 2000 to that in 2006?
Your answer should be very brief. 0.59. What is the ratio of the Grants(current US$) in Bolivia in 2001 to that in 2002?
Your answer should be compact. 1.09. What is the ratio of the Grants(current US$) in Myanmar in 2001 to that in 2002?
Your answer should be compact. 0.94. What is the ratio of the Grants(current US$) in Turkmenistan in 2001 to that in 2002?
Your answer should be compact. 0.97. What is the ratio of the Grants(current US$) of Zambia in 2001 to that in 2002?
Provide a short and direct response. 0.84. What is the ratio of the Grants(current US$) in Bolivia in 2001 to that in 2003?
Your answer should be very brief. 0.87. What is the ratio of the Grants(current US$) of Myanmar in 2001 to that in 2003?
Your response must be concise. 1.05. What is the ratio of the Grants(current US$) of Turkmenistan in 2001 to that in 2003?
Ensure brevity in your answer.  1.31. What is the ratio of the Grants(current US$) of Zambia in 2001 to that in 2003?
Offer a very short reply. 0.8. What is the ratio of the Grants(current US$) in Bolivia in 2001 to that in 2004?
Ensure brevity in your answer.  0.96. What is the ratio of the Grants(current US$) of Myanmar in 2001 to that in 2004?
Give a very brief answer. 1.54. What is the ratio of the Grants(current US$) of Turkmenistan in 2001 to that in 2004?
Your response must be concise. 0.58. What is the ratio of the Grants(current US$) of Zambia in 2001 to that in 2004?
Your answer should be very brief. 0.68. What is the ratio of the Grants(current US$) of Bolivia in 2001 to that in 2005?
Give a very brief answer. 0.96. What is the ratio of the Grants(current US$) in Myanmar in 2001 to that in 2005?
Give a very brief answer. 1.45. What is the ratio of the Grants(current US$) of Turkmenistan in 2001 to that in 2005?
Keep it short and to the point. 0.68. What is the ratio of the Grants(current US$) of Zambia in 2001 to that in 2005?
Provide a succinct answer. 0.59. What is the ratio of the Grants(current US$) of Bolivia in 2001 to that in 2006?
Ensure brevity in your answer.  0.76. What is the ratio of the Grants(current US$) of Myanmar in 2001 to that in 2006?
Ensure brevity in your answer.  1.61. What is the ratio of the Grants(current US$) of Turkmenistan in 2001 to that in 2006?
Ensure brevity in your answer.  0.75. What is the ratio of the Grants(current US$) of Zambia in 2001 to that in 2006?
Provide a short and direct response. 0.53. What is the ratio of the Grants(current US$) in Bolivia in 2002 to that in 2003?
Make the answer very short. 0.8. What is the ratio of the Grants(current US$) of Myanmar in 2002 to that in 2003?
Make the answer very short. 1.12. What is the ratio of the Grants(current US$) in Turkmenistan in 2002 to that in 2003?
Give a very brief answer. 1.35. What is the ratio of the Grants(current US$) of Zambia in 2002 to that in 2003?
Provide a succinct answer. 0.95. What is the ratio of the Grants(current US$) in Bolivia in 2002 to that in 2004?
Your answer should be very brief. 0.89. What is the ratio of the Grants(current US$) in Myanmar in 2002 to that in 2004?
Offer a very short reply. 1.63. What is the ratio of the Grants(current US$) in Turkmenistan in 2002 to that in 2004?
Keep it short and to the point. 0.6. What is the ratio of the Grants(current US$) of Zambia in 2002 to that in 2004?
Make the answer very short. 0.8. What is the ratio of the Grants(current US$) in Bolivia in 2002 to that in 2005?
Provide a succinct answer. 0.88. What is the ratio of the Grants(current US$) in Myanmar in 2002 to that in 2005?
Your response must be concise. 1.54. What is the ratio of the Grants(current US$) of Turkmenistan in 2002 to that in 2005?
Keep it short and to the point. 0.7. What is the ratio of the Grants(current US$) in Zambia in 2002 to that in 2005?
Make the answer very short. 0.7. What is the ratio of the Grants(current US$) of Bolivia in 2002 to that in 2006?
Offer a terse response. 0.7. What is the ratio of the Grants(current US$) in Myanmar in 2002 to that in 2006?
Your answer should be compact. 1.7. What is the ratio of the Grants(current US$) in Turkmenistan in 2002 to that in 2006?
Your response must be concise. 0.77. What is the ratio of the Grants(current US$) in Zambia in 2002 to that in 2006?
Offer a terse response. 0.63. What is the ratio of the Grants(current US$) of Bolivia in 2003 to that in 2004?
Keep it short and to the point. 1.11. What is the ratio of the Grants(current US$) of Myanmar in 2003 to that in 2004?
Your answer should be compact. 1.46. What is the ratio of the Grants(current US$) in Turkmenistan in 2003 to that in 2004?
Offer a very short reply. 0.44. What is the ratio of the Grants(current US$) of Zambia in 2003 to that in 2004?
Give a very brief answer. 0.84. What is the ratio of the Grants(current US$) of Bolivia in 2003 to that in 2005?
Provide a succinct answer. 1.11. What is the ratio of the Grants(current US$) of Myanmar in 2003 to that in 2005?
Your answer should be very brief. 1.38. What is the ratio of the Grants(current US$) of Turkmenistan in 2003 to that in 2005?
Provide a short and direct response. 0.52. What is the ratio of the Grants(current US$) of Zambia in 2003 to that in 2005?
Offer a terse response. 0.74. What is the ratio of the Grants(current US$) of Bolivia in 2003 to that in 2006?
Make the answer very short. 0.88. What is the ratio of the Grants(current US$) in Myanmar in 2003 to that in 2006?
Your response must be concise. 1.53. What is the ratio of the Grants(current US$) of Turkmenistan in 2003 to that in 2006?
Your answer should be very brief. 0.57. What is the ratio of the Grants(current US$) of Zambia in 2003 to that in 2006?
Offer a terse response. 0.67. What is the ratio of the Grants(current US$) in Myanmar in 2004 to that in 2005?
Provide a short and direct response. 0.94. What is the ratio of the Grants(current US$) in Turkmenistan in 2004 to that in 2005?
Offer a terse response. 1.16. What is the ratio of the Grants(current US$) of Zambia in 2004 to that in 2005?
Offer a very short reply. 0.88. What is the ratio of the Grants(current US$) in Bolivia in 2004 to that in 2006?
Provide a short and direct response. 0.79. What is the ratio of the Grants(current US$) in Myanmar in 2004 to that in 2006?
Keep it short and to the point. 1.04. What is the ratio of the Grants(current US$) of Turkmenistan in 2004 to that in 2006?
Your response must be concise. 1.29. What is the ratio of the Grants(current US$) of Zambia in 2004 to that in 2006?
Your answer should be compact. 0.79. What is the ratio of the Grants(current US$) in Bolivia in 2005 to that in 2006?
Keep it short and to the point. 0.79. What is the ratio of the Grants(current US$) in Myanmar in 2005 to that in 2006?
Ensure brevity in your answer.  1.11. What is the ratio of the Grants(current US$) of Turkmenistan in 2005 to that in 2006?
Give a very brief answer. 1.11. What is the ratio of the Grants(current US$) in Zambia in 2005 to that in 2006?
Provide a succinct answer. 0.9. What is the difference between the highest and the second highest Grants(current US$) of Bolivia?
Your response must be concise. 3.74e+07. What is the difference between the highest and the second highest Grants(current US$) in Myanmar?
Give a very brief answer. 3.32e+06. What is the difference between the highest and the second highest Grants(current US$) in Turkmenistan?
Your answer should be compact. 3.90e+06. What is the difference between the highest and the second highest Grants(current US$) in Zambia?
Keep it short and to the point. 1.79e+07. What is the difference between the highest and the lowest Grants(current US$) in Bolivia?
Provide a short and direct response. 1.55e+08. What is the difference between the highest and the lowest Grants(current US$) in Myanmar?
Your answer should be compact. 2.40e+07. What is the difference between the highest and the lowest Grants(current US$) of Turkmenistan?
Provide a short and direct response. 1.62e+07. What is the difference between the highest and the lowest Grants(current US$) of Zambia?
Keep it short and to the point. 8.55e+07. 